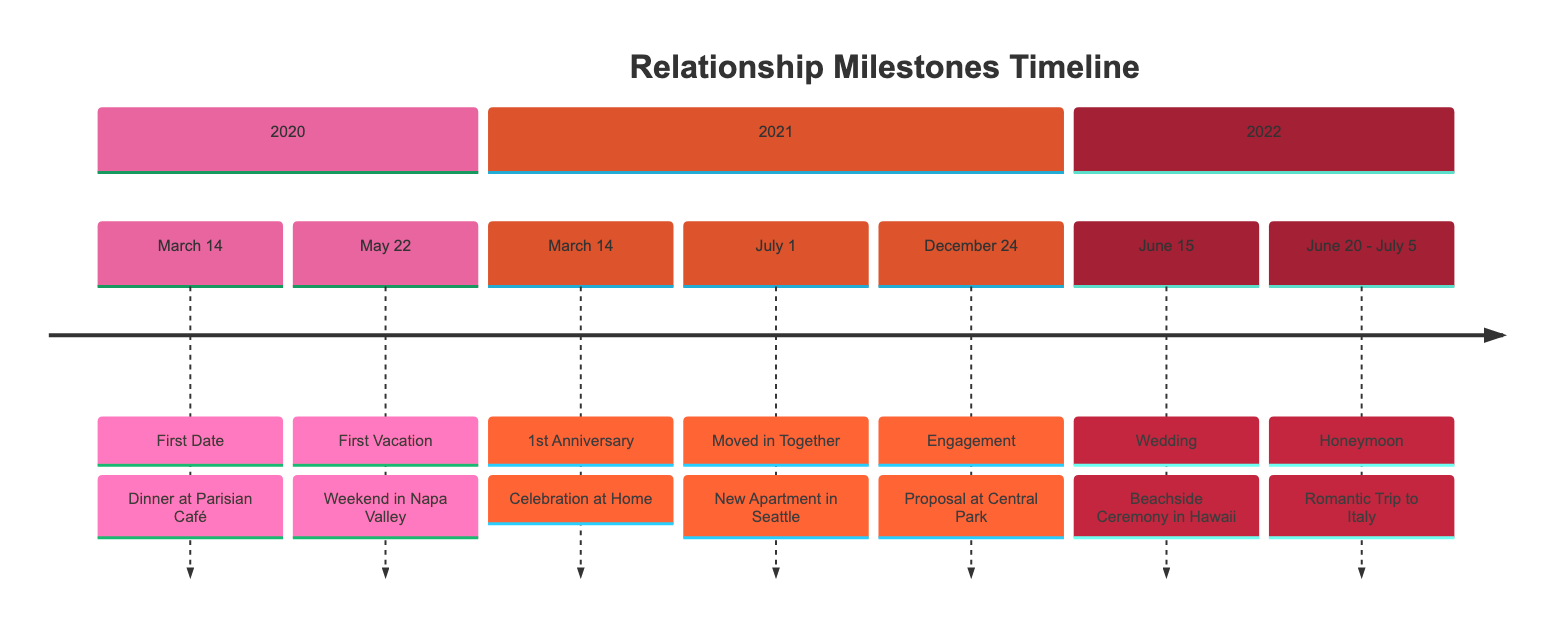What milestone occurred on March 14, 2020? The diagram shows "First Date" as the milestone on March 14, 2020, with the description being "Dinner at Parisian Café."
Answer: First Date How many anniversaries are listed in the timeline? Looking through the timeline, there is one notable anniversary listed: the 1st Anniversary on March 14, 2021. Therefore, the total is one anniversary.
Answer: 1 What event took place on December 24, 2021? The diagram indicates that on December 24, 2021, the milestone is an "Engagement," which occurred at Central Park.
Answer: Engagement Which event marks the couple moving in together? The diagram indicates that the event marking the couple moving in together occurred on July 1, 2021, represented as "Moved in Together" at their new apartment in Seattle.
Answer: Moved in Together How long was their honeymoon? The timeline spans from June 20 to July 5, 2022, indicating that the honeymoon lasted 15 days in total. To find this, we simply count the days from the start date to the end date.
Answer: 15 days In which year did they get married? From the diagram, the wedding took place on June 15, 2022, which makes the wedding year 2022. This can be found by identifying the date and correlating it with the section headers.
Answer: 2022 What significant event happened on June 15, 2022? The diagram notes that June 15, 2022, is marked by the "Wedding," which was a beachside ceremony in Hawaii. Therefore, it was a significant event.
Answer: Wedding Which vacation was their first together? The timeline indicates that the first vacation was taken on May 22, 2020, described as a "Weekend in Napa Valley." This information is visible in the 2020 section.
Answer: First Vacation What unique feature does this diagram have about the events? This diagram uniquely organizes the events chronologically within separate sections designated by years, making it visually clear which milestones occurred in which year, allowing for easy understanding of the progression of the relationship.
Answer: Chronological organization 